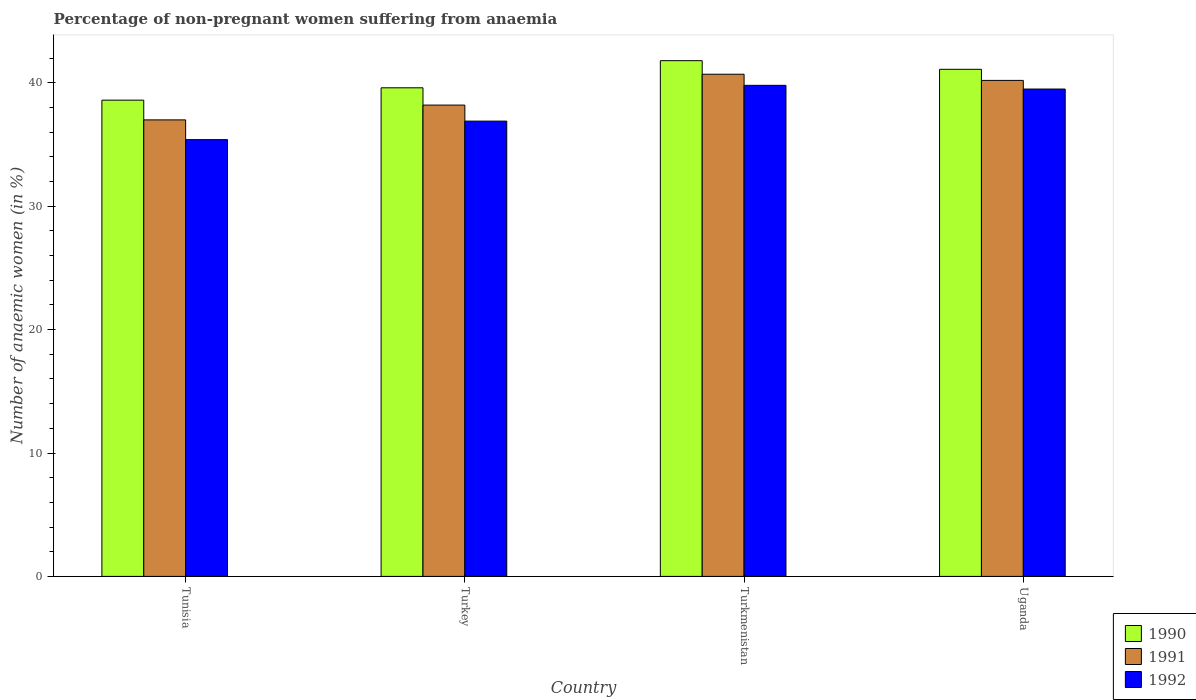How many different coloured bars are there?
Make the answer very short. 3. How many groups of bars are there?
Provide a succinct answer. 4. Are the number of bars per tick equal to the number of legend labels?
Provide a short and direct response. Yes. How many bars are there on the 2nd tick from the left?
Keep it short and to the point. 3. What is the label of the 1st group of bars from the left?
Your answer should be very brief. Tunisia. In how many cases, is the number of bars for a given country not equal to the number of legend labels?
Provide a short and direct response. 0. What is the percentage of non-pregnant women suffering from anaemia in 1990 in Turkmenistan?
Ensure brevity in your answer.  41.8. Across all countries, what is the maximum percentage of non-pregnant women suffering from anaemia in 1990?
Offer a very short reply. 41.8. Across all countries, what is the minimum percentage of non-pregnant women suffering from anaemia in 1990?
Give a very brief answer. 38.6. In which country was the percentage of non-pregnant women suffering from anaemia in 1992 maximum?
Offer a very short reply. Turkmenistan. In which country was the percentage of non-pregnant women suffering from anaemia in 1991 minimum?
Provide a succinct answer. Tunisia. What is the total percentage of non-pregnant women suffering from anaemia in 1992 in the graph?
Make the answer very short. 151.6. What is the difference between the percentage of non-pregnant women suffering from anaemia in 1992 in Turkey and that in Uganda?
Make the answer very short. -2.6. What is the difference between the percentage of non-pregnant women suffering from anaemia in 1990 in Turkey and the percentage of non-pregnant women suffering from anaemia in 1991 in Uganda?
Make the answer very short. -0.6. What is the average percentage of non-pregnant women suffering from anaemia in 1990 per country?
Provide a succinct answer. 40.27. What is the difference between the percentage of non-pregnant women suffering from anaemia of/in 1992 and percentage of non-pregnant women suffering from anaemia of/in 1991 in Turkey?
Provide a short and direct response. -1.3. In how many countries, is the percentage of non-pregnant women suffering from anaemia in 1991 greater than 36 %?
Provide a short and direct response. 4. What is the ratio of the percentage of non-pregnant women suffering from anaemia in 1990 in Tunisia to that in Turkmenistan?
Provide a succinct answer. 0.92. Is the percentage of non-pregnant women suffering from anaemia in 1991 in Turkey less than that in Uganda?
Keep it short and to the point. Yes. Is the difference between the percentage of non-pregnant women suffering from anaemia in 1992 in Turkey and Uganda greater than the difference between the percentage of non-pregnant women suffering from anaemia in 1991 in Turkey and Uganda?
Ensure brevity in your answer.  No. What is the difference between the highest and the second highest percentage of non-pregnant women suffering from anaemia in 1992?
Offer a terse response. -2.6. What is the difference between the highest and the lowest percentage of non-pregnant women suffering from anaemia in 1992?
Provide a short and direct response. 4.4. Is the sum of the percentage of non-pregnant women suffering from anaemia in 1992 in Tunisia and Turkmenistan greater than the maximum percentage of non-pregnant women suffering from anaemia in 1991 across all countries?
Your response must be concise. Yes. What does the 3rd bar from the right in Turkmenistan represents?
Your answer should be compact. 1990. Is it the case that in every country, the sum of the percentage of non-pregnant women suffering from anaemia in 1991 and percentage of non-pregnant women suffering from anaemia in 1990 is greater than the percentage of non-pregnant women suffering from anaemia in 1992?
Your answer should be compact. Yes. Are all the bars in the graph horizontal?
Offer a terse response. No. What is the difference between two consecutive major ticks on the Y-axis?
Make the answer very short. 10. Are the values on the major ticks of Y-axis written in scientific E-notation?
Offer a very short reply. No. Does the graph contain any zero values?
Provide a short and direct response. No. Where does the legend appear in the graph?
Offer a very short reply. Bottom right. How are the legend labels stacked?
Your response must be concise. Vertical. What is the title of the graph?
Your answer should be compact. Percentage of non-pregnant women suffering from anaemia. Does "1985" appear as one of the legend labels in the graph?
Make the answer very short. No. What is the label or title of the Y-axis?
Offer a very short reply. Number of anaemic women (in %). What is the Number of anaemic women (in %) in 1990 in Tunisia?
Your response must be concise. 38.6. What is the Number of anaemic women (in %) in 1991 in Tunisia?
Make the answer very short. 37. What is the Number of anaemic women (in %) of 1992 in Tunisia?
Provide a short and direct response. 35.4. What is the Number of anaemic women (in %) of 1990 in Turkey?
Make the answer very short. 39.6. What is the Number of anaemic women (in %) in 1991 in Turkey?
Give a very brief answer. 38.2. What is the Number of anaemic women (in %) of 1992 in Turkey?
Offer a terse response. 36.9. What is the Number of anaemic women (in %) of 1990 in Turkmenistan?
Your response must be concise. 41.8. What is the Number of anaemic women (in %) in 1991 in Turkmenistan?
Ensure brevity in your answer.  40.7. What is the Number of anaemic women (in %) in 1992 in Turkmenistan?
Provide a succinct answer. 39.8. What is the Number of anaemic women (in %) of 1990 in Uganda?
Keep it short and to the point. 41.1. What is the Number of anaemic women (in %) in 1991 in Uganda?
Provide a short and direct response. 40.2. What is the Number of anaemic women (in %) of 1992 in Uganda?
Provide a succinct answer. 39.5. Across all countries, what is the maximum Number of anaemic women (in %) in 1990?
Provide a succinct answer. 41.8. Across all countries, what is the maximum Number of anaemic women (in %) in 1991?
Your response must be concise. 40.7. Across all countries, what is the maximum Number of anaemic women (in %) in 1992?
Provide a short and direct response. 39.8. Across all countries, what is the minimum Number of anaemic women (in %) in 1990?
Offer a terse response. 38.6. Across all countries, what is the minimum Number of anaemic women (in %) in 1991?
Your answer should be very brief. 37. Across all countries, what is the minimum Number of anaemic women (in %) of 1992?
Give a very brief answer. 35.4. What is the total Number of anaemic women (in %) of 1990 in the graph?
Your answer should be very brief. 161.1. What is the total Number of anaemic women (in %) of 1991 in the graph?
Give a very brief answer. 156.1. What is the total Number of anaemic women (in %) in 1992 in the graph?
Your response must be concise. 151.6. What is the difference between the Number of anaemic women (in %) of 1990 in Tunisia and that in Turkmenistan?
Offer a very short reply. -3.2. What is the difference between the Number of anaemic women (in %) in 1991 in Tunisia and that in Turkmenistan?
Your answer should be compact. -3.7. What is the difference between the Number of anaemic women (in %) in 1990 in Turkey and that in Turkmenistan?
Provide a short and direct response. -2.2. What is the difference between the Number of anaemic women (in %) in 1991 in Turkey and that in Turkmenistan?
Your answer should be very brief. -2.5. What is the difference between the Number of anaemic women (in %) in 1992 in Turkey and that in Turkmenistan?
Provide a short and direct response. -2.9. What is the difference between the Number of anaemic women (in %) of 1992 in Turkey and that in Uganda?
Offer a terse response. -2.6. What is the difference between the Number of anaemic women (in %) of 1990 in Turkmenistan and that in Uganda?
Provide a short and direct response. 0.7. What is the difference between the Number of anaemic women (in %) in 1990 in Tunisia and the Number of anaemic women (in %) in 1991 in Turkey?
Give a very brief answer. 0.4. What is the difference between the Number of anaemic women (in %) of 1990 in Tunisia and the Number of anaemic women (in %) of 1992 in Turkey?
Ensure brevity in your answer.  1.7. What is the difference between the Number of anaemic women (in %) in 1991 in Tunisia and the Number of anaemic women (in %) in 1992 in Turkey?
Provide a short and direct response. 0.1. What is the difference between the Number of anaemic women (in %) in 1990 in Tunisia and the Number of anaemic women (in %) in 1991 in Turkmenistan?
Your answer should be very brief. -2.1. What is the difference between the Number of anaemic women (in %) in 1990 in Tunisia and the Number of anaemic women (in %) in 1992 in Turkmenistan?
Give a very brief answer. -1.2. What is the difference between the Number of anaemic women (in %) in 1991 in Tunisia and the Number of anaemic women (in %) in 1992 in Uganda?
Give a very brief answer. -2.5. What is the difference between the Number of anaemic women (in %) in 1990 in Turkey and the Number of anaemic women (in %) in 1992 in Turkmenistan?
Your answer should be very brief. -0.2. What is the difference between the Number of anaemic women (in %) of 1990 in Turkey and the Number of anaemic women (in %) of 1991 in Uganda?
Offer a terse response. -0.6. What is the difference between the Number of anaemic women (in %) of 1990 in Turkey and the Number of anaemic women (in %) of 1992 in Uganda?
Your answer should be very brief. 0.1. What is the difference between the Number of anaemic women (in %) in 1990 in Turkmenistan and the Number of anaemic women (in %) in 1991 in Uganda?
Ensure brevity in your answer.  1.6. What is the difference between the Number of anaemic women (in %) of 1991 in Turkmenistan and the Number of anaemic women (in %) of 1992 in Uganda?
Your answer should be very brief. 1.2. What is the average Number of anaemic women (in %) of 1990 per country?
Your answer should be compact. 40.27. What is the average Number of anaemic women (in %) of 1991 per country?
Provide a short and direct response. 39.02. What is the average Number of anaemic women (in %) in 1992 per country?
Your answer should be compact. 37.9. What is the difference between the Number of anaemic women (in %) of 1991 and Number of anaemic women (in %) of 1992 in Tunisia?
Your response must be concise. 1.6. What is the difference between the Number of anaemic women (in %) of 1990 and Number of anaemic women (in %) of 1992 in Turkey?
Provide a short and direct response. 2.7. What is the difference between the Number of anaemic women (in %) of 1990 and Number of anaemic women (in %) of 1991 in Turkmenistan?
Keep it short and to the point. 1.1. What is the difference between the Number of anaemic women (in %) of 1991 and Number of anaemic women (in %) of 1992 in Uganda?
Give a very brief answer. 0.7. What is the ratio of the Number of anaemic women (in %) in 1990 in Tunisia to that in Turkey?
Your answer should be compact. 0.97. What is the ratio of the Number of anaemic women (in %) in 1991 in Tunisia to that in Turkey?
Provide a short and direct response. 0.97. What is the ratio of the Number of anaemic women (in %) of 1992 in Tunisia to that in Turkey?
Your answer should be very brief. 0.96. What is the ratio of the Number of anaemic women (in %) of 1990 in Tunisia to that in Turkmenistan?
Give a very brief answer. 0.92. What is the ratio of the Number of anaemic women (in %) in 1992 in Tunisia to that in Turkmenistan?
Give a very brief answer. 0.89. What is the ratio of the Number of anaemic women (in %) in 1990 in Tunisia to that in Uganda?
Keep it short and to the point. 0.94. What is the ratio of the Number of anaemic women (in %) in 1991 in Tunisia to that in Uganda?
Your response must be concise. 0.92. What is the ratio of the Number of anaemic women (in %) in 1992 in Tunisia to that in Uganda?
Your answer should be compact. 0.9. What is the ratio of the Number of anaemic women (in %) of 1991 in Turkey to that in Turkmenistan?
Offer a very short reply. 0.94. What is the ratio of the Number of anaemic women (in %) in 1992 in Turkey to that in Turkmenistan?
Make the answer very short. 0.93. What is the ratio of the Number of anaemic women (in %) of 1990 in Turkey to that in Uganda?
Offer a terse response. 0.96. What is the ratio of the Number of anaemic women (in %) in 1991 in Turkey to that in Uganda?
Keep it short and to the point. 0.95. What is the ratio of the Number of anaemic women (in %) of 1992 in Turkey to that in Uganda?
Provide a short and direct response. 0.93. What is the ratio of the Number of anaemic women (in %) of 1990 in Turkmenistan to that in Uganda?
Provide a succinct answer. 1.02. What is the ratio of the Number of anaemic women (in %) in 1991 in Turkmenistan to that in Uganda?
Your answer should be very brief. 1.01. What is the ratio of the Number of anaemic women (in %) of 1992 in Turkmenistan to that in Uganda?
Provide a short and direct response. 1.01. What is the difference between the highest and the second highest Number of anaemic women (in %) in 1990?
Provide a succinct answer. 0.7. What is the difference between the highest and the second highest Number of anaemic women (in %) of 1991?
Provide a succinct answer. 0.5. What is the difference between the highest and the lowest Number of anaemic women (in %) in 1991?
Provide a short and direct response. 3.7. 